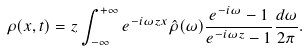Convert formula to latex. <formula><loc_0><loc_0><loc_500><loc_500>\rho ( x , t ) = z \int _ { - \infty } ^ { + \infty } e ^ { - i \omega z x } \hat { \rho } ( \omega ) \frac { e ^ { - i \omega } - 1 } { e ^ { - i \omega z } - 1 } \frac { d \omega } { 2 \pi } .</formula> 